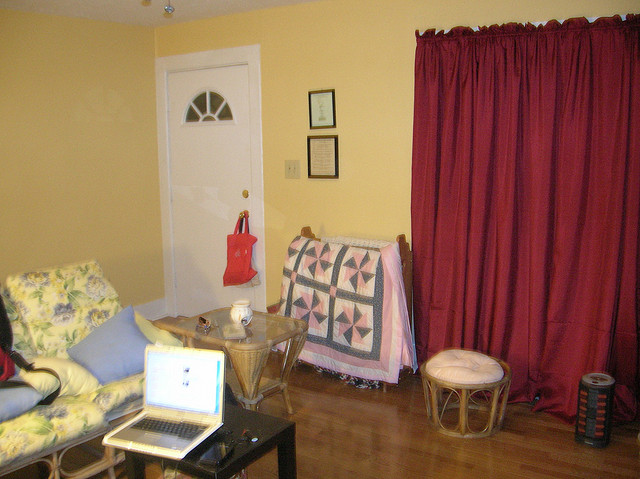<image>What holiday is the room decorated for? The room is not decorated for any specific holiday. However, some answers suggest it could be for Easter or Thanksgiving. What holiday is the room decorated for? It is unknown what holiday the room is decorated for. 